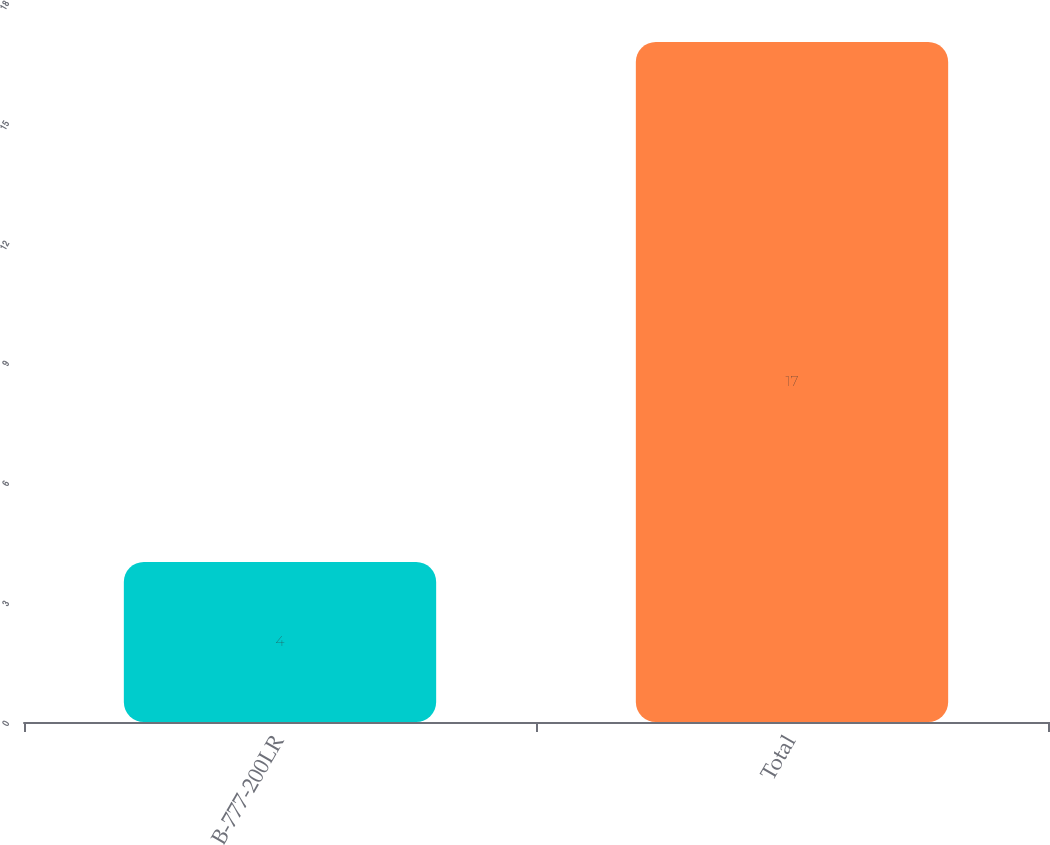Convert chart to OTSL. <chart><loc_0><loc_0><loc_500><loc_500><bar_chart><fcel>B-777-200LR<fcel>Total<nl><fcel>4<fcel>17<nl></chart> 